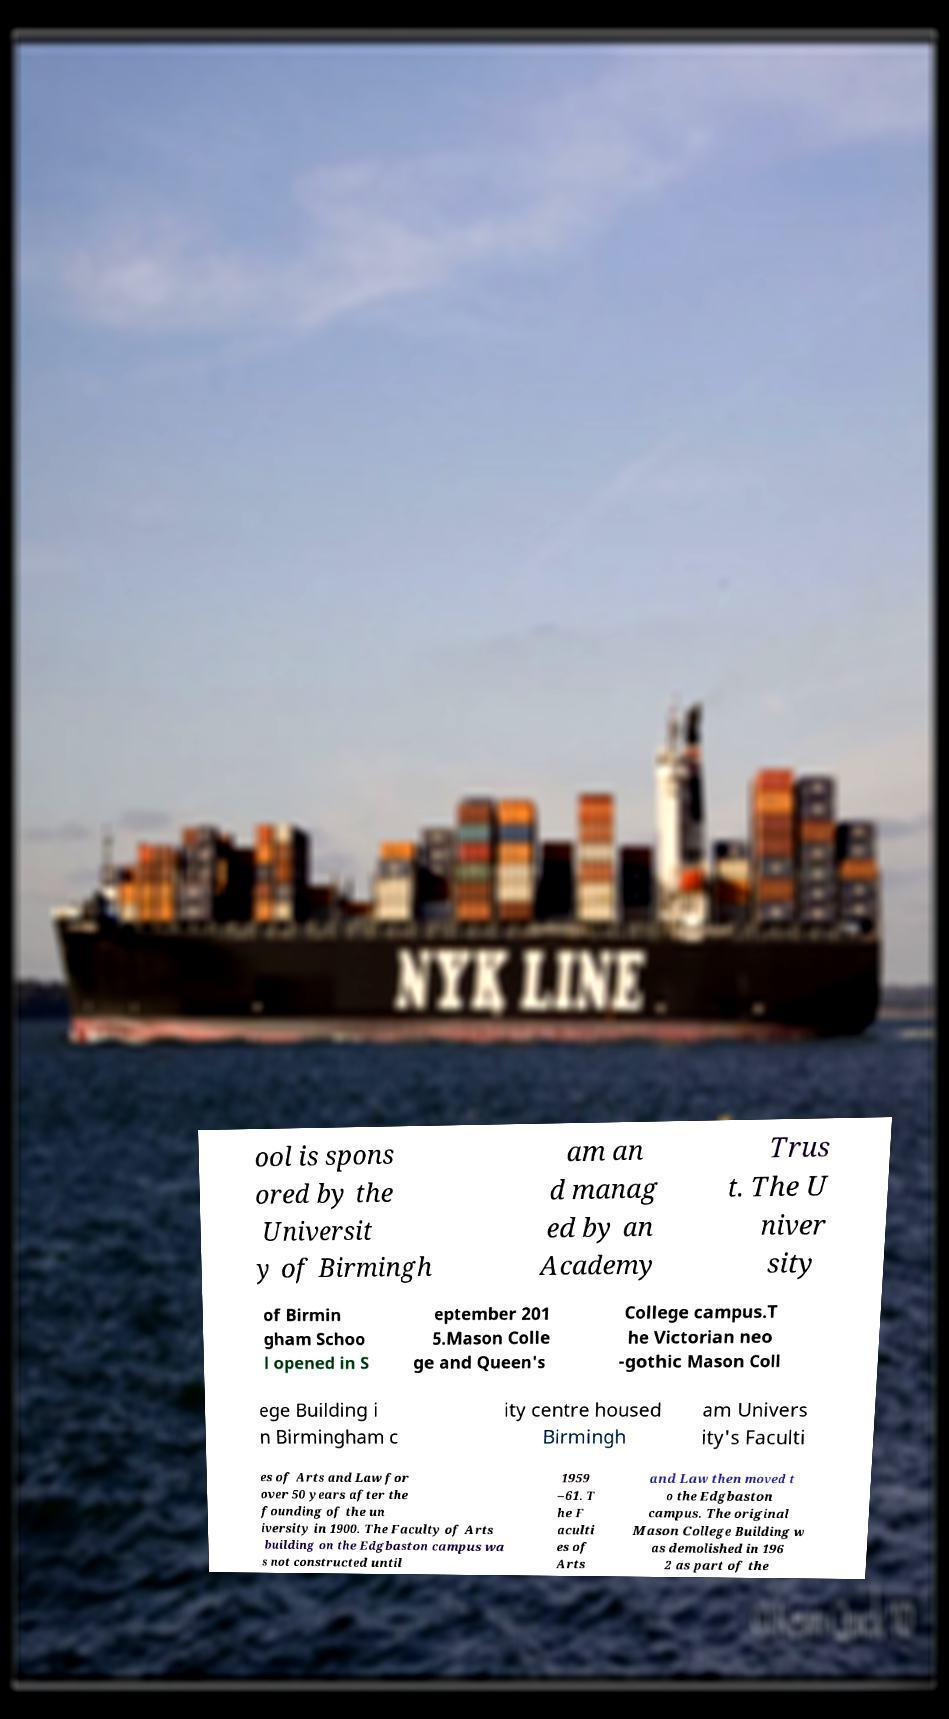I need the written content from this picture converted into text. Can you do that? ool is spons ored by the Universit y of Birmingh am an d manag ed by an Academy Trus t. The U niver sity of Birmin gham Schoo l opened in S eptember 201 5.Mason Colle ge and Queen's College campus.T he Victorian neo -gothic Mason Coll ege Building i n Birmingham c ity centre housed Birmingh am Univers ity's Faculti es of Arts and Law for over 50 years after the founding of the un iversity in 1900. The Faculty of Arts building on the Edgbaston campus wa s not constructed until 1959 –61. T he F aculti es of Arts and Law then moved t o the Edgbaston campus. The original Mason College Building w as demolished in 196 2 as part of the 